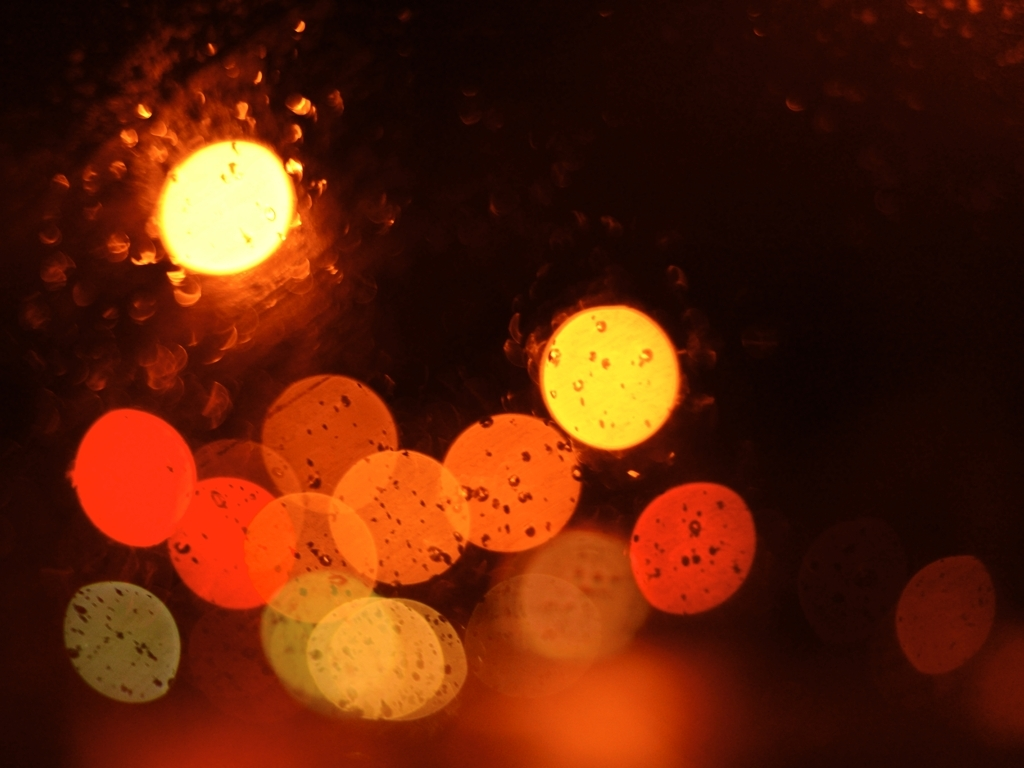What might have caused the colorful pattern in this picture? The colorful pattern results from light passing through droplets of water on a glass surface. The droplets scatter the light and create enlarged, out-of-focus circles known as bokeh, commonly seen in photographs taken at night with points of light in the background. 